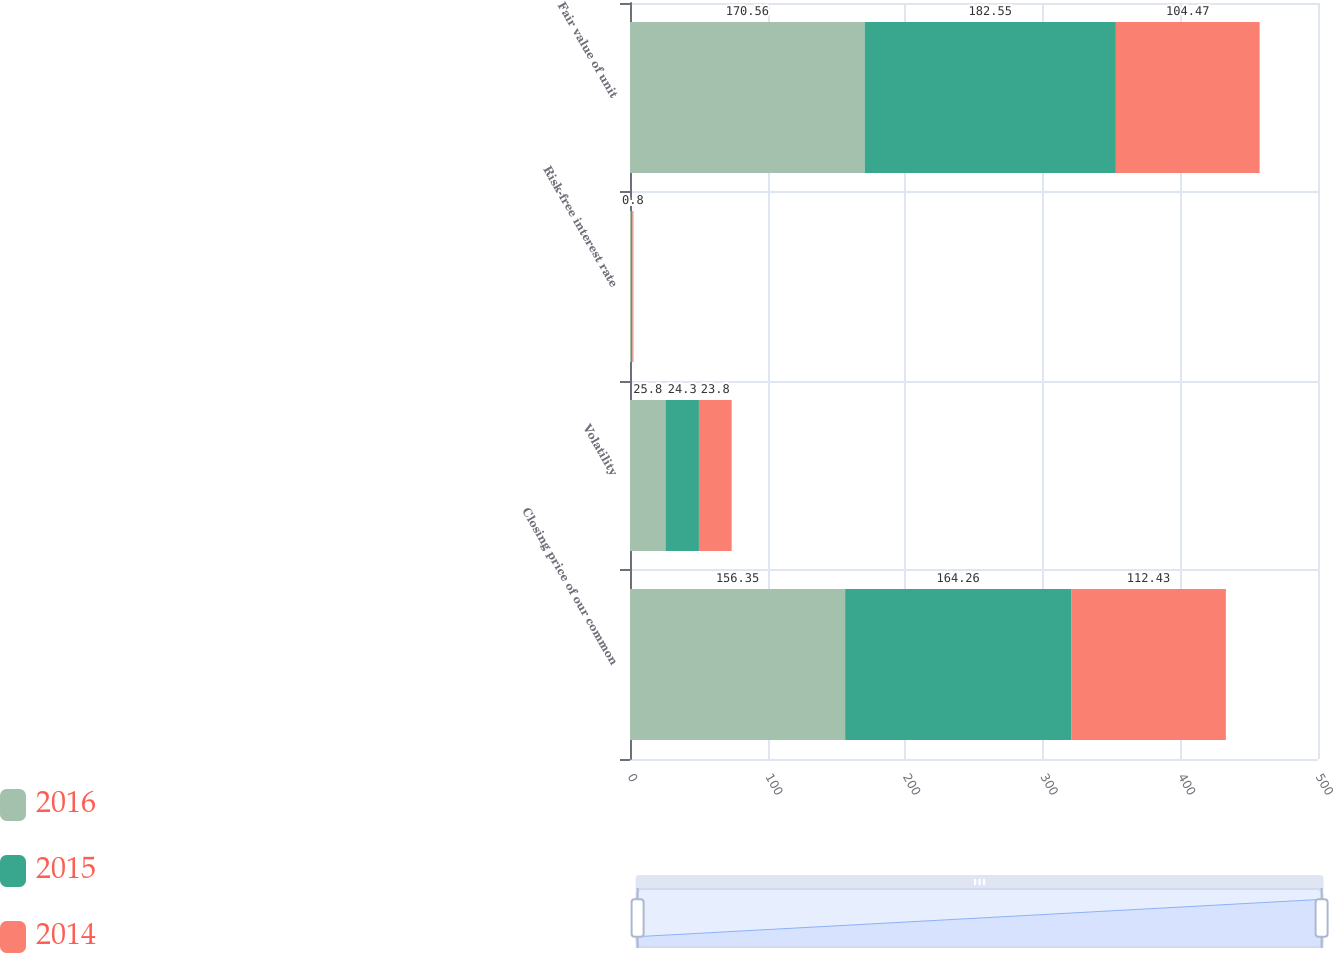<chart> <loc_0><loc_0><loc_500><loc_500><stacked_bar_chart><ecel><fcel>Closing price of our common<fcel>Volatility<fcel>Risk-free interest rate<fcel>Fair value of unit<nl><fcel>2016<fcel>156.35<fcel>25.8<fcel>0.9<fcel>170.56<nl><fcel>2015<fcel>164.26<fcel>24.3<fcel>0.8<fcel>182.55<nl><fcel>2014<fcel>112.43<fcel>23.8<fcel>0.8<fcel>104.47<nl></chart> 